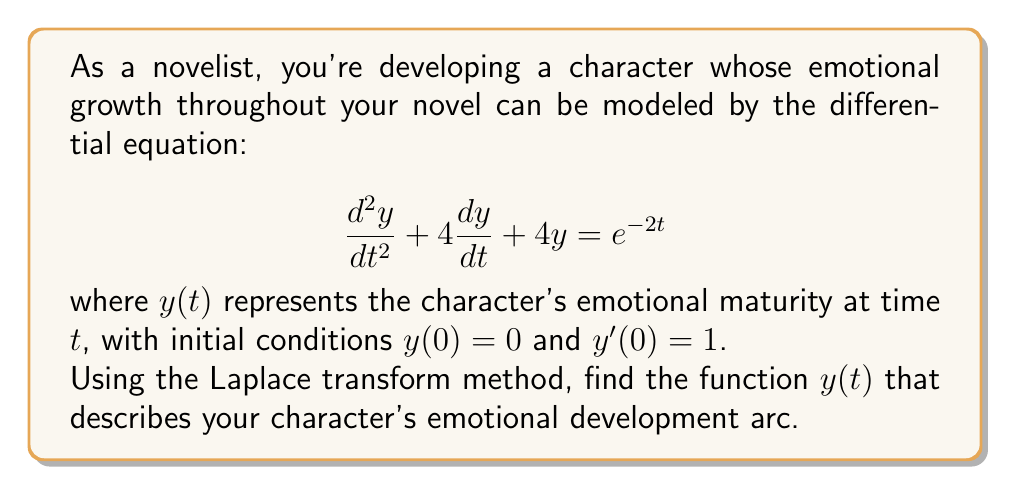Give your solution to this math problem. Let's solve this step-by-step using the Laplace transform method:

1) Take the Laplace transform of both sides of the equation:
   $$\mathcal{L}\{y''(t) + 4y'(t) + 4y(t)\} = \mathcal{L}\{e^{-2t}\}$$

2) Using Laplace transform properties:
   $$(s^2Y(s) - sy(0) - y'(0)) + 4(sY(s) - y(0)) + 4Y(s) = \frac{1}{s+2}$$

3) Substitute the initial conditions $y(0) = 0$ and $y'(0) = 1$:
   $$(s^2Y(s) - 1) + 4sY(s) + 4Y(s) = \frac{1}{s+2}$$

4) Simplify:
   $$(s^2 + 4s + 4)Y(s) = \frac{1}{s+2} + 1$$

5) Solve for $Y(s)$:
   $$Y(s) = \frac{1}{s^2 + 4s + 4} \cdot (\frac{1}{s+2} + 1) = \frac{1}{(s+2)^2} \cdot (\frac{1}{s+2} + 1)$$

6) Partial fraction decomposition:
   $$Y(s) = \frac{1}{(s+2)^3} + \frac{1}{(s+2)^2}$$

7) Take the inverse Laplace transform:
   $$y(t) = \mathcal{L}^{-1}\{\frac{1}{(s+2)^3} + \frac{1}{(s+2)^2}\}$$

8) Using inverse Laplace transform properties:
   $$y(t) = \frac{1}{2}t^2e^{-2t} + te^{-2t}$$

This function $y(t)$ describes the character's emotional development arc over time.
Answer: $y(t) = \frac{1}{2}t^2e^{-2t} + te^{-2t}$ 